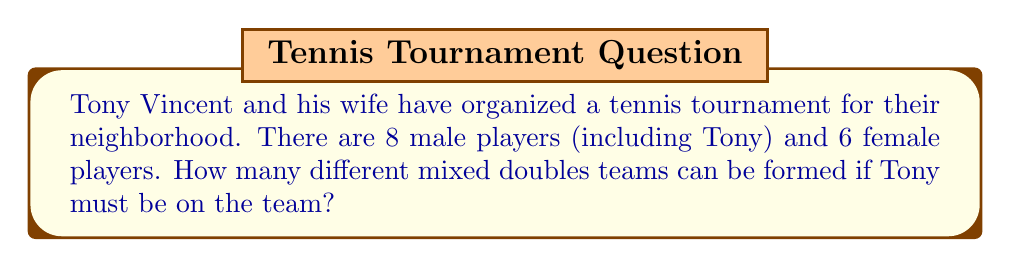Can you solve this math problem? Let's break this down step-by-step:

1) A mixed doubles team consists of one male and one female player.

2) Tony must be on the team, so he's already selected as the male player.

3) We only need to choose the female player to complete the team.

4) There are 6 female players to choose from.

5) This is a simple combination problem where we're selecting 1 player from a group of 6.

6) The formula for this combination is:

   $$C(6,1) = \frac{6!}{1!(6-1)!} = \frac{6!}{1!5!}$$

7) Simplifying:
   $$\frac{6 * 5!}{1 * 5!} = 6$$

Therefore, there are 6 different ways to form a mixed doubles team with Tony.
Answer: 6 